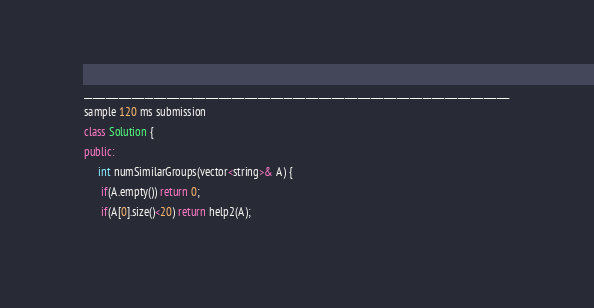Convert code to text. <code><loc_0><loc_0><loc_500><loc_500><_C++_>__________________________________________________________________________________________________
sample 120 ms submission
class Solution {
public:
     int numSimilarGroups(vector<string>& A) {
      if(A.empty()) return 0;
      if(A[0].size()<20) return help2(A);</code> 